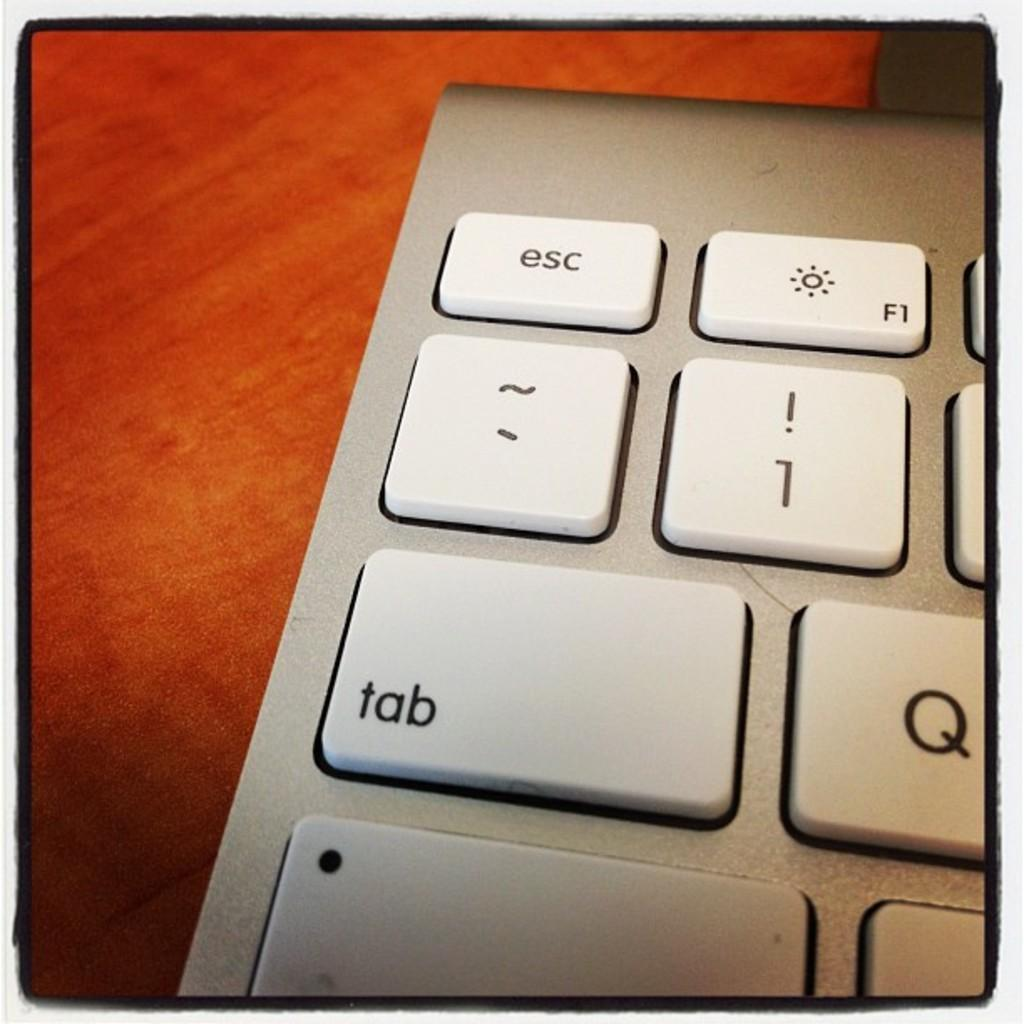Provide a one-sentence caption for the provided image. Close up of a keyboard with the tab key prominent. 